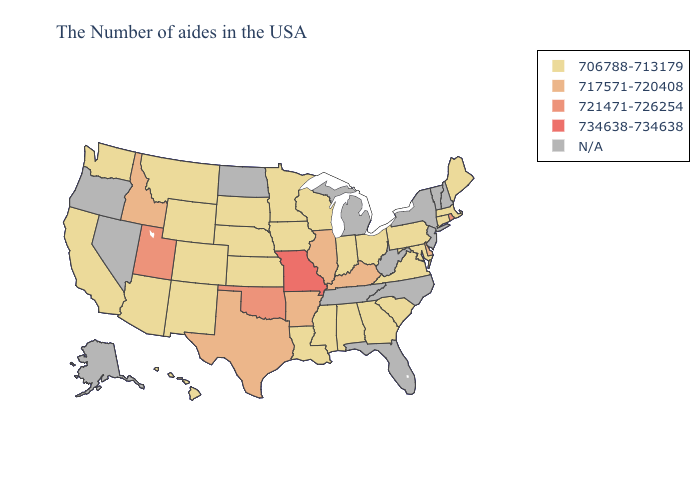Does Illinois have the lowest value in the USA?
Answer briefly. No. Among the states that border Nevada , does Utah have the lowest value?
Keep it brief. No. What is the highest value in the MidWest ?
Write a very short answer. 734638-734638. How many symbols are there in the legend?
Short answer required. 5. Name the states that have a value in the range 706788-713179?
Write a very short answer. Maine, Massachusetts, Connecticut, Maryland, Pennsylvania, Virginia, South Carolina, Ohio, Georgia, Indiana, Alabama, Wisconsin, Mississippi, Louisiana, Minnesota, Iowa, Kansas, Nebraska, South Dakota, Wyoming, Colorado, New Mexico, Montana, Arizona, California, Washington, Hawaii. What is the lowest value in the South?
Answer briefly. 706788-713179. What is the value of Oklahoma?
Short answer required. 721471-726254. Does the first symbol in the legend represent the smallest category?
Give a very brief answer. Yes. Which states have the lowest value in the Northeast?
Be succinct. Maine, Massachusetts, Connecticut, Pennsylvania. What is the lowest value in the MidWest?
Be succinct. 706788-713179. Name the states that have a value in the range 717571-720408?
Keep it brief. Delaware, Kentucky, Illinois, Arkansas, Texas, Idaho. Name the states that have a value in the range 734638-734638?
Write a very short answer. Missouri. 